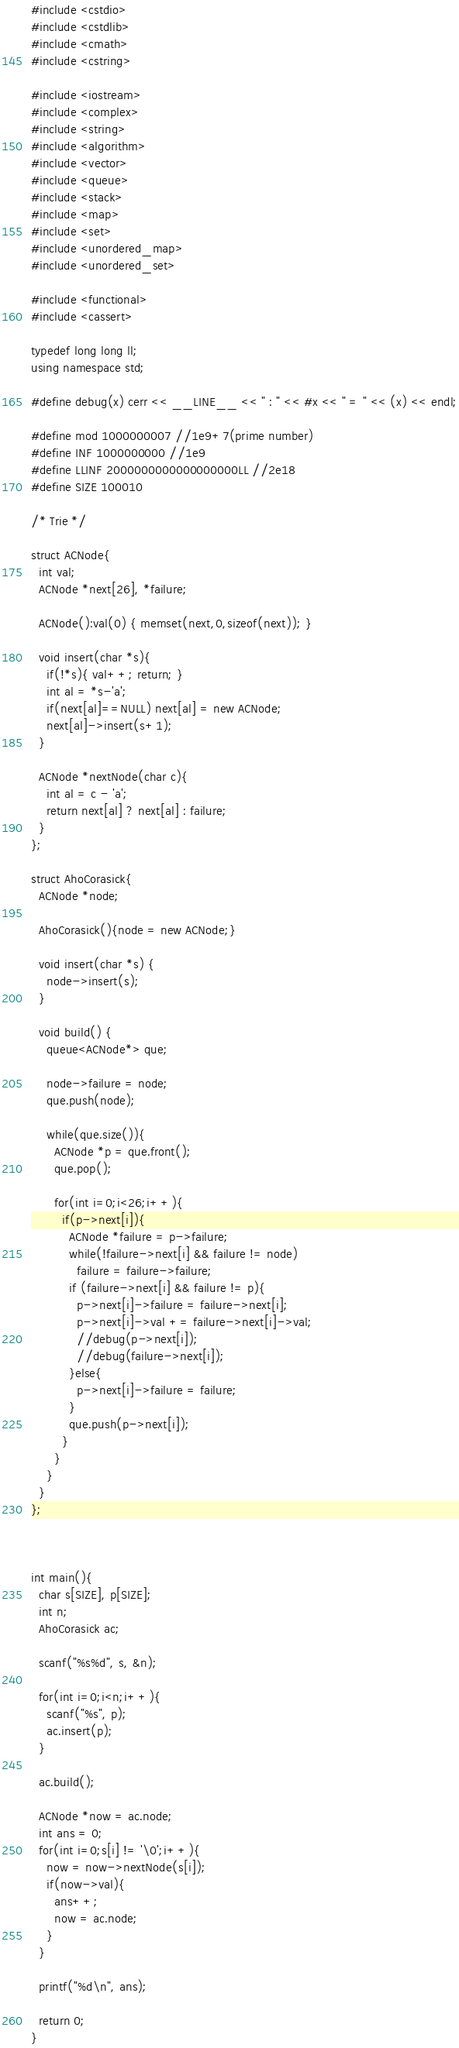Convert code to text. <code><loc_0><loc_0><loc_500><loc_500><_C++_>#include <cstdio>
#include <cstdlib>
#include <cmath>
#include <cstring>

#include <iostream>
#include <complex>
#include <string>
#include <algorithm>
#include <vector>
#include <queue>
#include <stack>
#include <map>
#include <set>
#include <unordered_map>
#include <unordered_set>

#include <functional>
#include <cassert>

typedef long long ll;
using namespace std;

#define debug(x) cerr << __LINE__ << " : " << #x << " = " << (x) << endl;

#define mod 1000000007 //1e9+7(prime number)
#define INF 1000000000 //1e9
#define LLINF 2000000000000000000LL //2e18
#define SIZE 100010

/* Trie */

struct ACNode{
  int val;
  ACNode *next[26], *failure;
  
  ACNode():val(0) { memset(next,0,sizeof(next)); }
  
  void insert(char *s){
    if(!*s){ val++; return; }
    int al = *s-'a';
    if(next[al]==NULL) next[al] = new ACNode;
    next[al]->insert(s+1);
  }

  ACNode *nextNode(char c){
    int al = c - 'a';
    return next[al] ? next[al] : failure;
  }
};

struct AhoCorasick{
  ACNode *node;

  AhoCorasick(){node = new ACNode;}
  
  void insert(char *s) {
    node->insert(s);
  }
  
  void build() {
    queue<ACNode*> que;

    node->failure = node;
    que.push(node);
    
    while(que.size()){
      ACNode *p = que.front();
      que.pop();
      
      for(int i=0;i<26;i++){
        if(p->next[i]){
          ACNode *failure = p->failure;
          while(!failure->next[i] && failure != node)
            failure = failure->failure;
          if (failure->next[i] && failure != p){
            p->next[i]->failure = failure->next[i];
            p->next[i]->val += failure->next[i]->val;
            //debug(p->next[i]);
            //debug(failure->next[i]);
          }else{
            p->next[i]->failure = failure;
          }
          que.push(p->next[i]);
        }
      }
    }
  }
};



int main(){
  char s[SIZE], p[SIZE];
  int n;
  AhoCorasick ac;
  
  scanf("%s%d", s, &n);
  
  for(int i=0;i<n;i++){
    scanf("%s", p);
    ac.insert(p);
  }

  ac.build();

  ACNode *now = ac.node;
  int ans = 0;
  for(int i=0;s[i] != '\0';i++){
    now = now->nextNode(s[i]);
    if(now->val){
      ans++;
      now = ac.node;
    }
  }

  printf("%d\n", ans);
  
  return 0;
}


</code> 